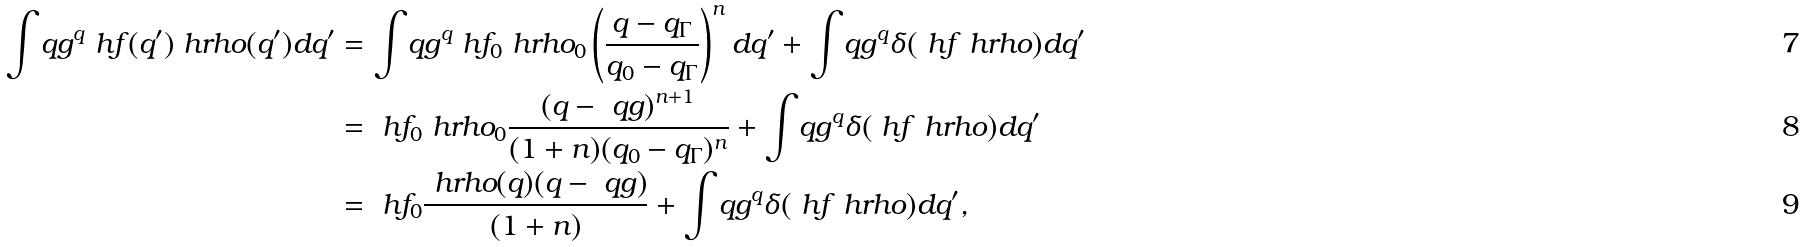Convert formula to latex. <formula><loc_0><loc_0><loc_500><loc_500>\int _ { \ } q g ^ { q } { \ h f ( q ^ { \prime } ) \ h r h o ( q ^ { \prime } ) d q ^ { \prime } } & = \int _ { \ } q g ^ { q } { \ h f _ { 0 } \ h r h o _ { 0 } \left ( \frac { q - q _ { \Gamma } } { q _ { 0 } - q _ { \Gamma } } \right ) ^ { n } d q ^ { \prime } } + \int _ { \ } q g ^ { q } { \delta ( \ h f \ h r h o ) d q ^ { \prime } } \\ & = \ h f _ { 0 } \ h r h o _ { 0 } \frac { ( q - \ q g ) ^ { n + 1 } } { ( 1 + n ) ( q _ { 0 } - q _ { \Gamma } ) ^ { n } } + \int _ { \ } q g ^ { q } { \delta ( \ h f \ h r h o ) d q ^ { \prime } } \\ & = \ h f _ { 0 } \frac { \ h r h o ( q ) ( q - \ q g ) } { ( 1 + n ) } + \int _ { \ } q g ^ { q } { \delta ( \ h f \ h r h o ) d q ^ { \prime } } ,</formula> 